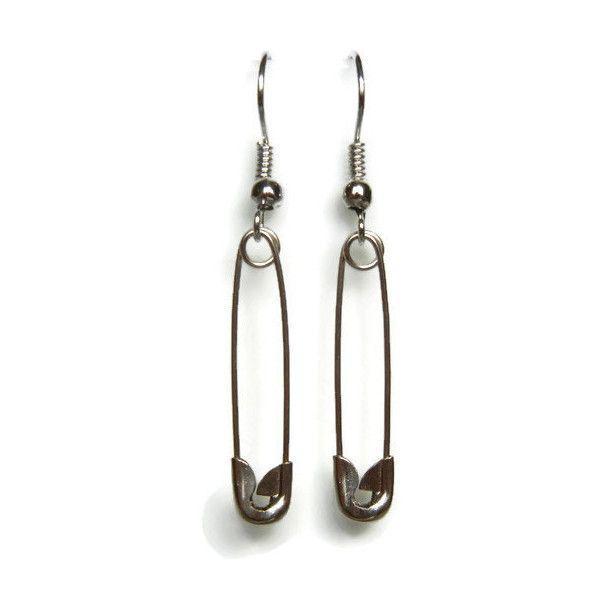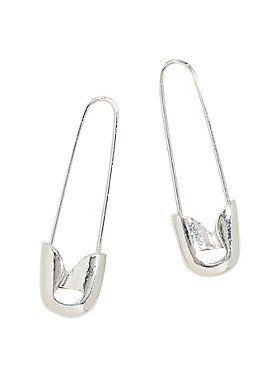The first image is the image on the left, the second image is the image on the right. Assess this claim about the two images: "In one image, no less than three safety pins are arranged in order next to each other by size". Correct or not? Answer yes or no. No. The first image is the image on the left, the second image is the image on the right. Given the left and right images, does the statement "An image shows exactly two safety pins, displayed with their clasp ends at the bottom and designed with no loop ends." hold true? Answer yes or no. Yes. 